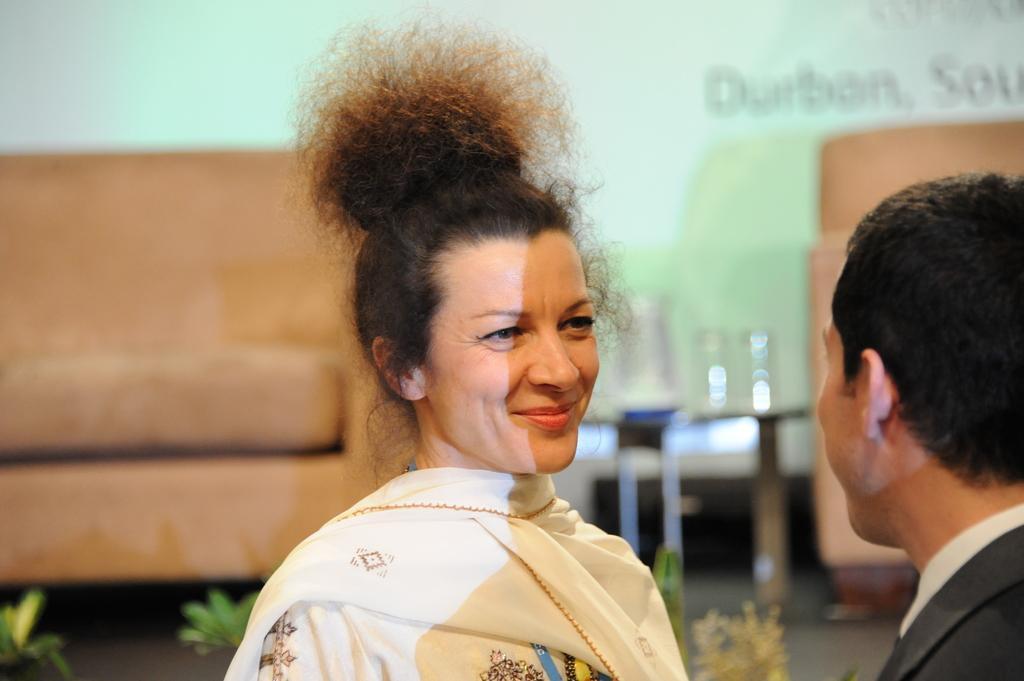In one or two sentences, can you explain what this image depicts? There are two people and she is smiling. In the background it is blurry and we can see sofas,plants and it is green color. 